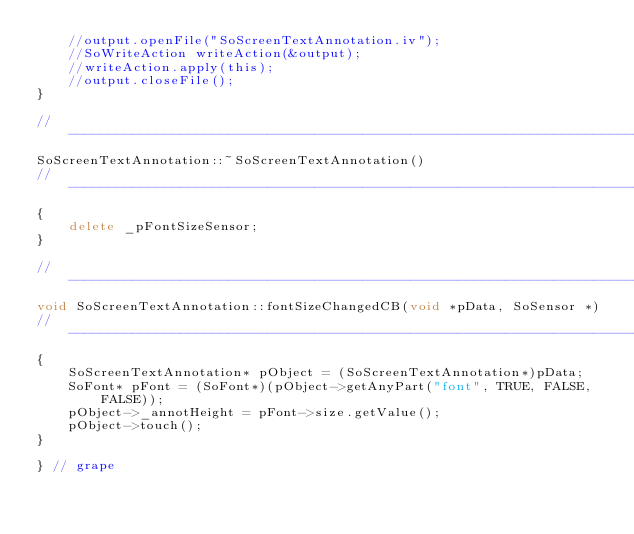Convert code to text. <code><loc_0><loc_0><loc_500><loc_500><_C++_>    //output.openFile("SoScreenTextAnnotation.iv");
    //SoWriteAction writeAction(&output);
    //writeAction.apply(this);
    //output.closeFile();
}

//------------------------------------------------------------------------------
SoScreenTextAnnotation::~SoScreenTextAnnotation()
//------------------------------------------------------------------------------
{
    delete _pFontSizeSensor;
}

//------------------------------------------------------------------------------
void SoScreenTextAnnotation::fontSizeChangedCB(void *pData, SoSensor *)
//------------------------------------------------------------------------------
{
    SoScreenTextAnnotation* pObject = (SoScreenTextAnnotation*)pData;
    SoFont* pFont = (SoFont*)(pObject->getAnyPart("font", TRUE, FALSE, FALSE));
    pObject->_annotHeight = pFont->size.getValue();
    pObject->touch();
}

} // grape
</code> 